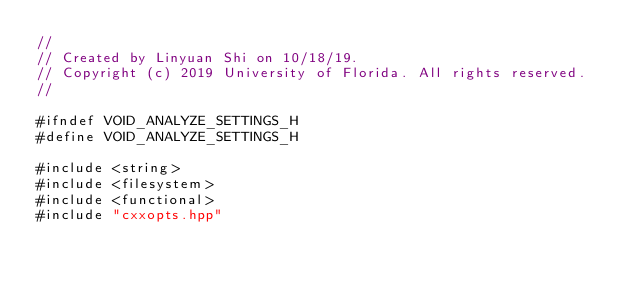<code> <loc_0><loc_0><loc_500><loc_500><_C_>//
// Created by Linyuan Shi on 10/18/19.
// Copyright (c) 2019 University of Florida. All rights reserved.
//

#ifndef VOID_ANALYZE_SETTINGS_H
#define VOID_ANALYZE_SETTINGS_H

#include <string>
#include <filesystem>
#include <functional>
#include "cxxopts.hpp"</code> 